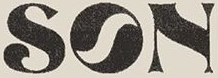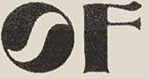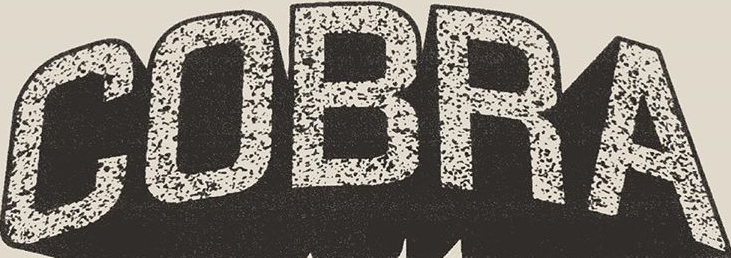What words are shown in these images in order, separated by a semicolon? SON; OF; COBRA 